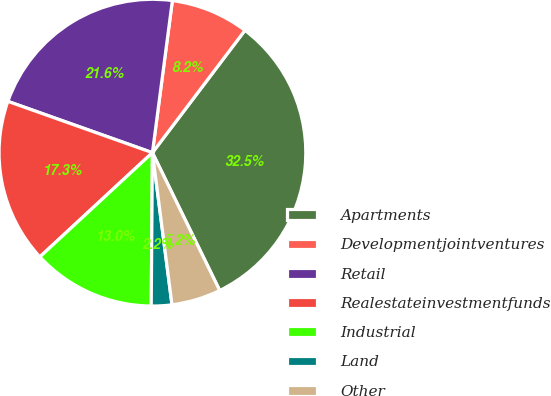Convert chart. <chart><loc_0><loc_0><loc_500><loc_500><pie_chart><fcel>Apartments<fcel>Developmentjointventures<fcel>Retail<fcel>Realestateinvestmentfunds<fcel>Industrial<fcel>Land<fcel>Other<nl><fcel>32.47%<fcel>8.23%<fcel>21.65%<fcel>17.32%<fcel>12.99%<fcel>2.16%<fcel>5.19%<nl></chart> 